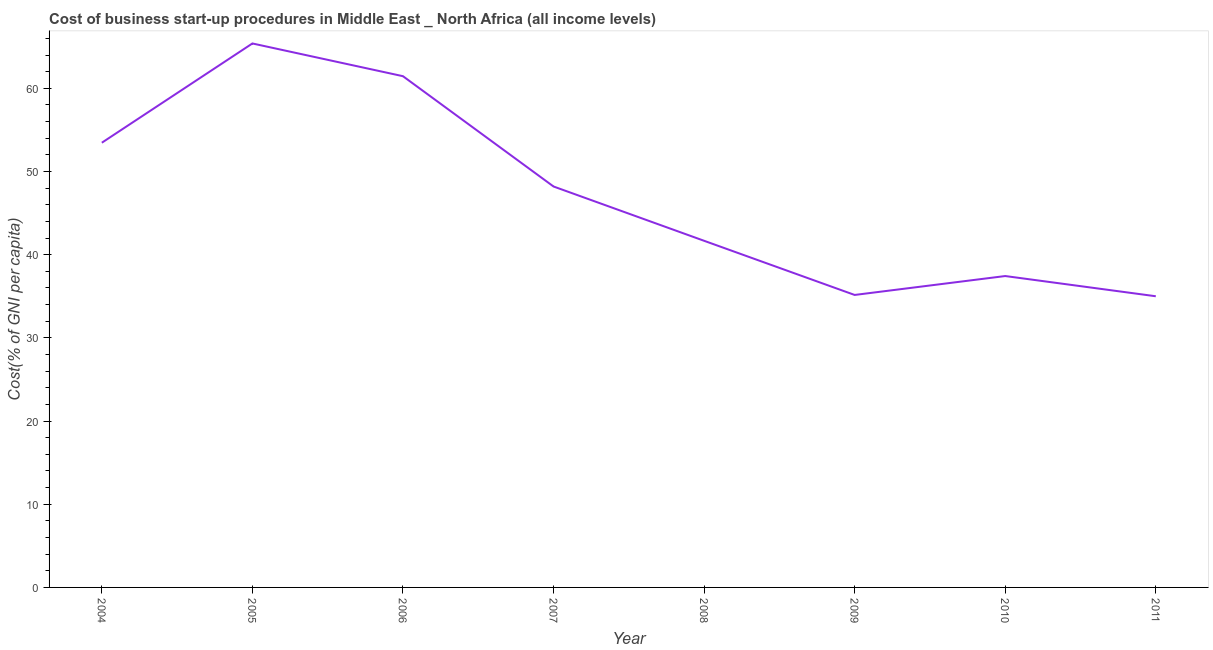What is the cost of business startup procedures in 2011?
Ensure brevity in your answer.  35. Across all years, what is the maximum cost of business startup procedures?
Your response must be concise. 65.39. In which year was the cost of business startup procedures maximum?
Make the answer very short. 2005. What is the sum of the cost of business startup procedures?
Keep it short and to the point. 377.75. What is the difference between the cost of business startup procedures in 2004 and 2010?
Your response must be concise. 16.02. What is the average cost of business startup procedures per year?
Offer a very short reply. 47.22. What is the median cost of business startup procedures?
Make the answer very short. 44.93. In how many years, is the cost of business startup procedures greater than 50 %?
Your answer should be very brief. 3. What is the ratio of the cost of business startup procedures in 2006 to that in 2009?
Your answer should be compact. 1.75. What is the difference between the highest and the second highest cost of business startup procedures?
Keep it short and to the point. 3.94. Is the sum of the cost of business startup procedures in 2004 and 2005 greater than the maximum cost of business startup procedures across all years?
Offer a very short reply. Yes. What is the difference between the highest and the lowest cost of business startup procedures?
Offer a terse response. 30.39. In how many years, is the cost of business startup procedures greater than the average cost of business startup procedures taken over all years?
Your answer should be very brief. 4. How many lines are there?
Your response must be concise. 1. What is the difference between two consecutive major ticks on the Y-axis?
Give a very brief answer. 10. Are the values on the major ticks of Y-axis written in scientific E-notation?
Ensure brevity in your answer.  No. Does the graph contain any zero values?
Give a very brief answer. No. What is the title of the graph?
Give a very brief answer. Cost of business start-up procedures in Middle East _ North Africa (all income levels). What is the label or title of the Y-axis?
Offer a very short reply. Cost(% of GNI per capita). What is the Cost(% of GNI per capita) in 2004?
Ensure brevity in your answer.  53.46. What is the Cost(% of GNI per capita) of 2005?
Offer a very short reply. 65.39. What is the Cost(% of GNI per capita) of 2006?
Provide a succinct answer. 61.45. What is the Cost(% of GNI per capita) of 2007?
Your answer should be compact. 48.19. What is the Cost(% of GNI per capita) in 2008?
Provide a short and direct response. 41.67. What is the Cost(% of GNI per capita) in 2009?
Provide a short and direct response. 35.16. What is the Cost(% of GNI per capita) in 2010?
Provide a succinct answer. 37.43. What is the Cost(% of GNI per capita) in 2011?
Your response must be concise. 35. What is the difference between the Cost(% of GNI per capita) in 2004 and 2005?
Provide a short and direct response. -11.93. What is the difference between the Cost(% of GNI per capita) in 2004 and 2006?
Give a very brief answer. -8. What is the difference between the Cost(% of GNI per capita) in 2004 and 2007?
Keep it short and to the point. 5.26. What is the difference between the Cost(% of GNI per capita) in 2004 and 2008?
Provide a short and direct response. 11.79. What is the difference between the Cost(% of GNI per capita) in 2004 and 2009?
Offer a very short reply. 18.3. What is the difference between the Cost(% of GNI per capita) in 2004 and 2010?
Provide a succinct answer. 16.02. What is the difference between the Cost(% of GNI per capita) in 2004 and 2011?
Make the answer very short. 18.46. What is the difference between the Cost(% of GNI per capita) in 2005 and 2006?
Keep it short and to the point. 3.94. What is the difference between the Cost(% of GNI per capita) in 2005 and 2007?
Make the answer very short. 17.19. What is the difference between the Cost(% of GNI per capita) in 2005 and 2008?
Make the answer very short. 23.72. What is the difference between the Cost(% of GNI per capita) in 2005 and 2009?
Provide a succinct answer. 30.23. What is the difference between the Cost(% of GNI per capita) in 2005 and 2010?
Your answer should be compact. 27.96. What is the difference between the Cost(% of GNI per capita) in 2005 and 2011?
Give a very brief answer. 30.39. What is the difference between the Cost(% of GNI per capita) in 2006 and 2007?
Provide a succinct answer. 13.26. What is the difference between the Cost(% of GNI per capita) in 2006 and 2008?
Give a very brief answer. 19.78. What is the difference between the Cost(% of GNI per capita) in 2006 and 2009?
Keep it short and to the point. 26.3. What is the difference between the Cost(% of GNI per capita) in 2006 and 2010?
Offer a terse response. 24.02. What is the difference between the Cost(% of GNI per capita) in 2006 and 2011?
Ensure brevity in your answer.  26.45. What is the difference between the Cost(% of GNI per capita) in 2007 and 2008?
Provide a short and direct response. 6.53. What is the difference between the Cost(% of GNI per capita) in 2007 and 2009?
Make the answer very short. 13.04. What is the difference between the Cost(% of GNI per capita) in 2007 and 2010?
Make the answer very short. 10.76. What is the difference between the Cost(% of GNI per capita) in 2007 and 2011?
Make the answer very short. 13.19. What is the difference between the Cost(% of GNI per capita) in 2008 and 2009?
Ensure brevity in your answer.  6.51. What is the difference between the Cost(% of GNI per capita) in 2008 and 2010?
Offer a very short reply. 4.24. What is the difference between the Cost(% of GNI per capita) in 2008 and 2011?
Keep it short and to the point. 6.67. What is the difference between the Cost(% of GNI per capita) in 2009 and 2010?
Provide a short and direct response. -2.27. What is the difference between the Cost(% of GNI per capita) in 2009 and 2011?
Keep it short and to the point. 0.16. What is the difference between the Cost(% of GNI per capita) in 2010 and 2011?
Your answer should be compact. 2.43. What is the ratio of the Cost(% of GNI per capita) in 2004 to that in 2005?
Offer a terse response. 0.82. What is the ratio of the Cost(% of GNI per capita) in 2004 to that in 2006?
Offer a terse response. 0.87. What is the ratio of the Cost(% of GNI per capita) in 2004 to that in 2007?
Your response must be concise. 1.11. What is the ratio of the Cost(% of GNI per capita) in 2004 to that in 2008?
Your answer should be compact. 1.28. What is the ratio of the Cost(% of GNI per capita) in 2004 to that in 2009?
Your answer should be compact. 1.52. What is the ratio of the Cost(% of GNI per capita) in 2004 to that in 2010?
Ensure brevity in your answer.  1.43. What is the ratio of the Cost(% of GNI per capita) in 2004 to that in 2011?
Keep it short and to the point. 1.53. What is the ratio of the Cost(% of GNI per capita) in 2005 to that in 2006?
Ensure brevity in your answer.  1.06. What is the ratio of the Cost(% of GNI per capita) in 2005 to that in 2007?
Ensure brevity in your answer.  1.36. What is the ratio of the Cost(% of GNI per capita) in 2005 to that in 2008?
Provide a succinct answer. 1.57. What is the ratio of the Cost(% of GNI per capita) in 2005 to that in 2009?
Keep it short and to the point. 1.86. What is the ratio of the Cost(% of GNI per capita) in 2005 to that in 2010?
Your answer should be compact. 1.75. What is the ratio of the Cost(% of GNI per capita) in 2005 to that in 2011?
Provide a short and direct response. 1.87. What is the ratio of the Cost(% of GNI per capita) in 2006 to that in 2007?
Keep it short and to the point. 1.27. What is the ratio of the Cost(% of GNI per capita) in 2006 to that in 2008?
Your answer should be very brief. 1.48. What is the ratio of the Cost(% of GNI per capita) in 2006 to that in 2009?
Your answer should be compact. 1.75. What is the ratio of the Cost(% of GNI per capita) in 2006 to that in 2010?
Make the answer very short. 1.64. What is the ratio of the Cost(% of GNI per capita) in 2006 to that in 2011?
Your answer should be compact. 1.76. What is the ratio of the Cost(% of GNI per capita) in 2007 to that in 2008?
Ensure brevity in your answer.  1.16. What is the ratio of the Cost(% of GNI per capita) in 2007 to that in 2009?
Make the answer very short. 1.37. What is the ratio of the Cost(% of GNI per capita) in 2007 to that in 2010?
Offer a terse response. 1.29. What is the ratio of the Cost(% of GNI per capita) in 2007 to that in 2011?
Your answer should be very brief. 1.38. What is the ratio of the Cost(% of GNI per capita) in 2008 to that in 2009?
Keep it short and to the point. 1.19. What is the ratio of the Cost(% of GNI per capita) in 2008 to that in 2010?
Provide a succinct answer. 1.11. What is the ratio of the Cost(% of GNI per capita) in 2008 to that in 2011?
Keep it short and to the point. 1.19. What is the ratio of the Cost(% of GNI per capita) in 2009 to that in 2010?
Make the answer very short. 0.94. What is the ratio of the Cost(% of GNI per capita) in 2009 to that in 2011?
Offer a terse response. 1. What is the ratio of the Cost(% of GNI per capita) in 2010 to that in 2011?
Your response must be concise. 1.07. 